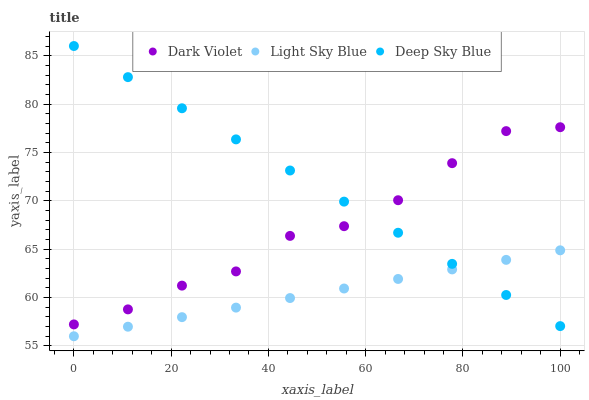Does Light Sky Blue have the minimum area under the curve?
Answer yes or no. Yes. Does Deep Sky Blue have the maximum area under the curve?
Answer yes or no. Yes. Does Dark Violet have the minimum area under the curve?
Answer yes or no. No. Does Dark Violet have the maximum area under the curve?
Answer yes or no. No. Is Deep Sky Blue the smoothest?
Answer yes or no. Yes. Is Dark Violet the roughest?
Answer yes or no. Yes. Is Dark Violet the smoothest?
Answer yes or no. No. Is Deep Sky Blue the roughest?
Answer yes or no. No. Does Light Sky Blue have the lowest value?
Answer yes or no. Yes. Does Deep Sky Blue have the lowest value?
Answer yes or no. No. Does Deep Sky Blue have the highest value?
Answer yes or no. Yes. Does Dark Violet have the highest value?
Answer yes or no. No. Is Light Sky Blue less than Dark Violet?
Answer yes or no. Yes. Is Dark Violet greater than Light Sky Blue?
Answer yes or no. Yes. Does Dark Violet intersect Deep Sky Blue?
Answer yes or no. Yes. Is Dark Violet less than Deep Sky Blue?
Answer yes or no. No. Is Dark Violet greater than Deep Sky Blue?
Answer yes or no. No. Does Light Sky Blue intersect Dark Violet?
Answer yes or no. No. 